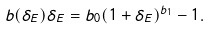Convert formula to latex. <formula><loc_0><loc_0><loc_500><loc_500>b ( \delta _ { E } ) \delta _ { E } = b _ { 0 } ( 1 + \delta _ { E } ) ^ { b _ { 1 } } - 1 .</formula> 